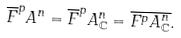Convert formula to latex. <formula><loc_0><loc_0><loc_500><loc_500>\overline { F } ^ { p } A ^ { n } = \overline { F } ^ { p } A ^ { n } _ { \mathbb { C } } = \overline { F ^ { p } A ^ { n } _ { \mathbb { C } } } .</formula> 